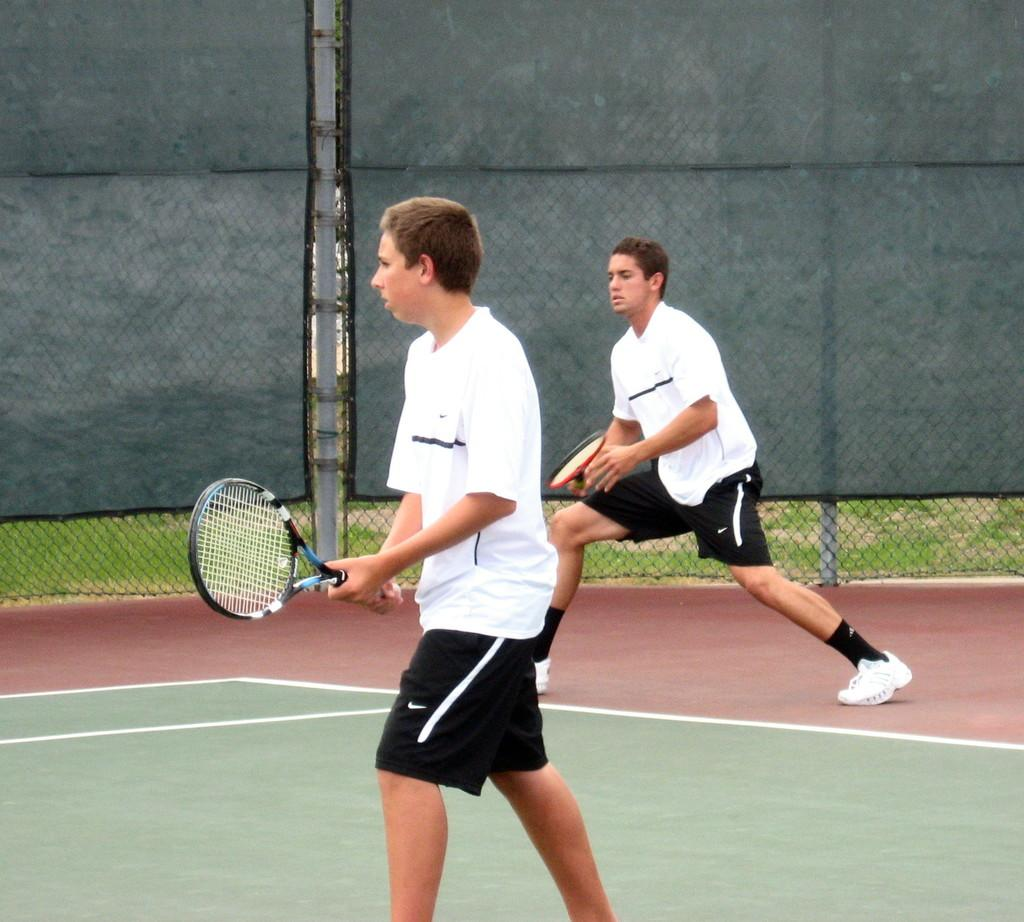How many people are in the image? There are two people in the image. What are the people doing in the image? The people are standing and holding tennis rackets, and they appear to be playing tennis. What can be seen in the background of the image? There is an iron fencing in the background of the image. How is the iron fencing covered in the image? The iron fencing is covered with a black sheet. What type of arm is visible on the tennis court in the image? There is no specific arm mentioned or visible in the image; it only shows two people playing tennis and an iron fencing covered with a black sheet in the background. 